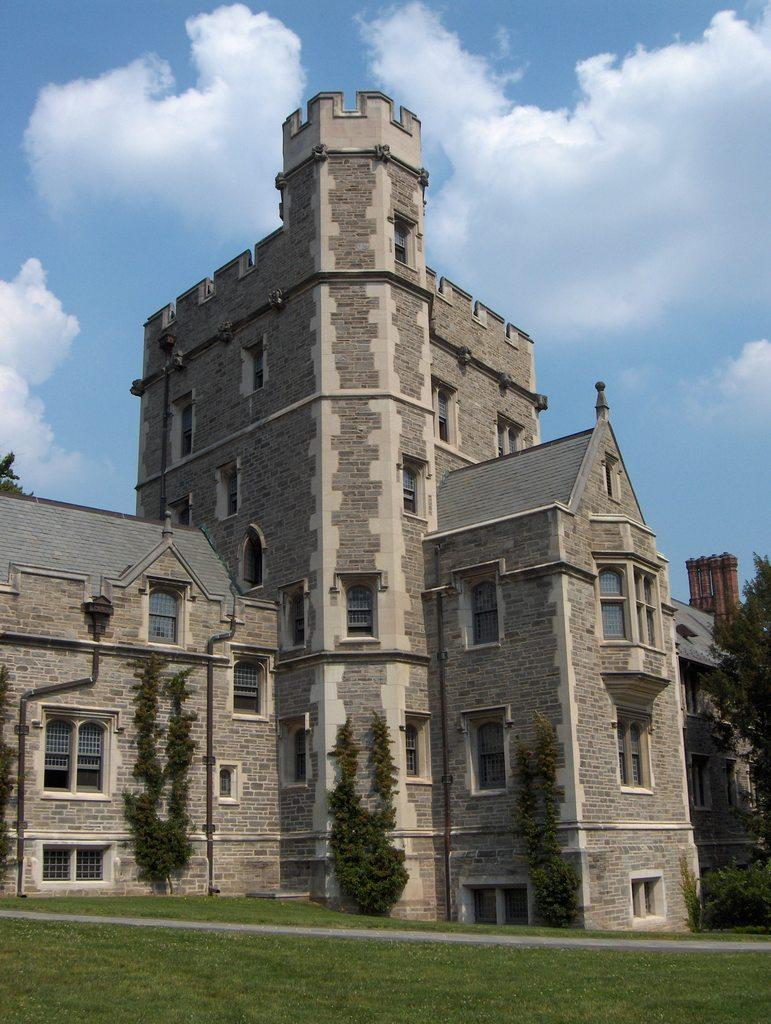What type of structure is visible in the image? There is a building with windows in the image. What is on the ground in the image? There is grass on the ground in the image. What other natural elements can be seen in the image? There are trees in the image. What is visible in the background of the image? The sky is visible in the background of the image. What can be observed in the sky? There are clouds in the sky. How many mice are sitting on the windowsill of the building in the image? There are no mice present in the image. What book is the person reading in the image? There is no person reading a book in the image. 